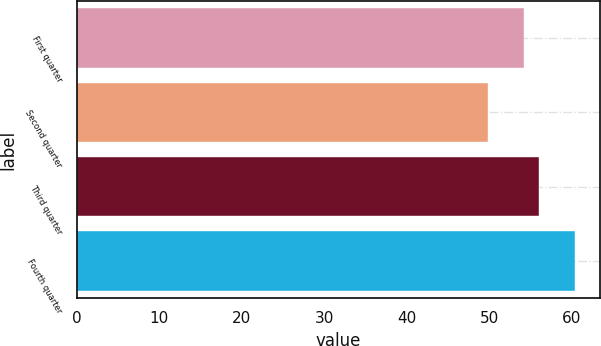Convert chart. <chart><loc_0><loc_0><loc_500><loc_500><bar_chart><fcel>First quarter<fcel>Second quarter<fcel>Third quarter<fcel>Fourth quarter<nl><fcel>54.18<fcel>49.91<fcel>56<fcel>60.43<nl></chart> 